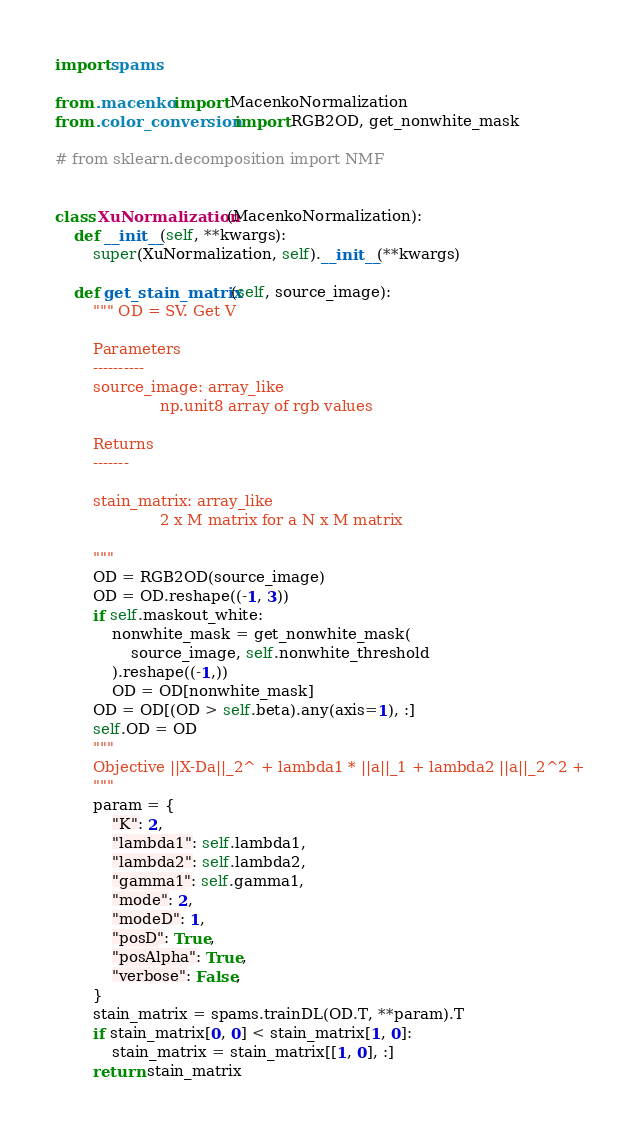<code> <loc_0><loc_0><loc_500><loc_500><_Python_>import spams

from .macenko import MacenkoNormalization
from .color_conversion import RGB2OD, get_nonwhite_mask

# from sklearn.decomposition import NMF


class XuNormalization(MacenkoNormalization):
    def __init__(self, **kwargs):
        super(XuNormalization, self).__init__(**kwargs)

    def get_stain_matrix(self, source_image):
        """ OD = SV. Get V

        Parameters
        ----------
        source_image: array_like
                      np.unit8 array of rgb values

        Returns
        -------

        stain_matrix: array_like
                      2 x M matrix for a N x M matrix

        """
        OD = RGB2OD(source_image)
        OD = OD.reshape((-1, 3))
        if self.maskout_white:
            nonwhite_mask = get_nonwhite_mask(
                source_image, self.nonwhite_threshold
            ).reshape((-1,))
            OD = OD[nonwhite_mask]
        OD = OD[(OD > self.beta).any(axis=1), :]
        self.OD = OD
        """
        Objective ||X-Da||_2^ + lambda1 * ||a||_1 + lambda2 ||a||_2^2 +
        """
        param = {
            "K": 2,
            "lambda1": self.lambda1,
            "lambda2": self.lambda2,
            "gamma1": self.gamma1,
            "mode": 2,
            "modeD": 1,
            "posD": True,
            "posAlpha": True,
            "verbose": False,
        }
        stain_matrix = spams.trainDL(OD.T, **param).T
        if stain_matrix[0, 0] < stain_matrix[1, 0]:
            stain_matrix = stain_matrix[[1, 0], :]
        return stain_matrix
</code> 